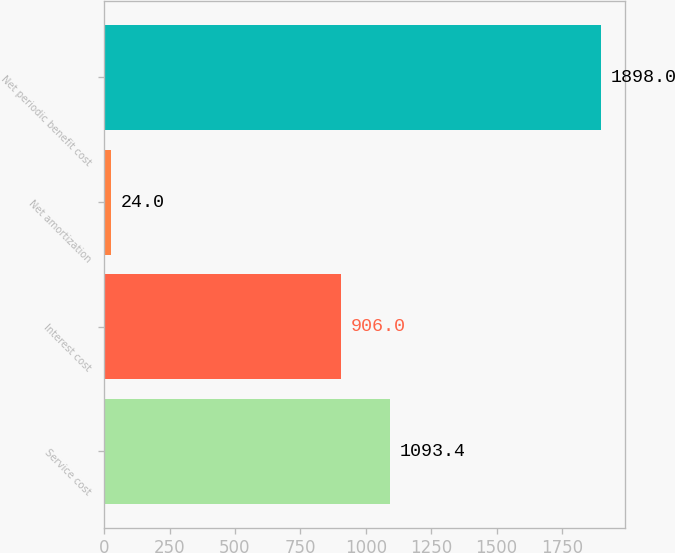Convert chart to OTSL. <chart><loc_0><loc_0><loc_500><loc_500><bar_chart><fcel>Service cost<fcel>Interest cost<fcel>Net amortization<fcel>Net periodic benefit cost<nl><fcel>1093.4<fcel>906<fcel>24<fcel>1898<nl></chart> 